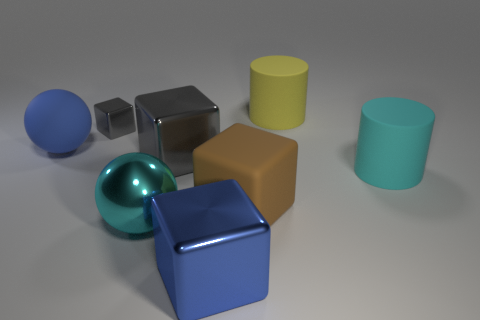Subtract all cyan blocks. Subtract all brown cylinders. How many blocks are left? 4 Add 2 large gray cubes. How many objects exist? 10 Subtract all balls. How many objects are left? 6 Subtract all yellow blocks. Subtract all big metal balls. How many objects are left? 7 Add 5 large brown rubber cubes. How many large brown rubber cubes are left? 6 Add 2 spheres. How many spheres exist? 4 Subtract 0 red balls. How many objects are left? 8 